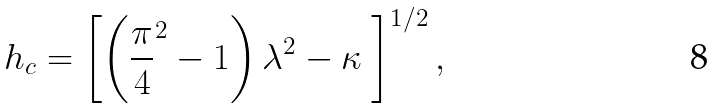<formula> <loc_0><loc_0><loc_500><loc_500>h _ { c } = \left [ \left ( \frac { \pi } { 4 } ^ { 2 } - 1 \right ) { \lambda } ^ { 2 } - \kappa \ \right ] ^ { 1 / 2 } ,</formula> 